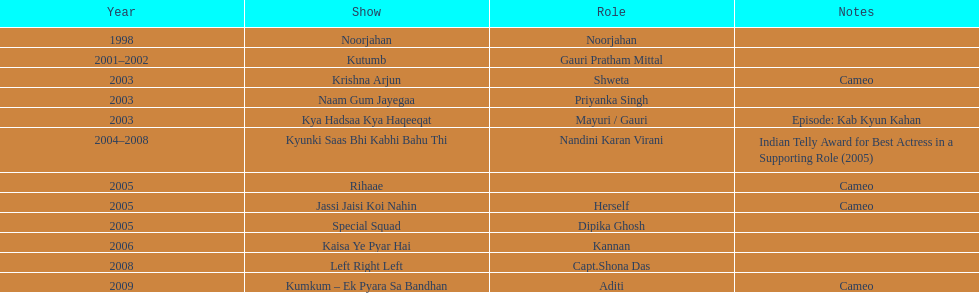Prior to 2000, how many distinct television programs featured gauri tejwani? 1. 